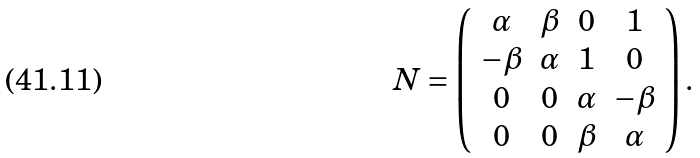Convert formula to latex. <formula><loc_0><loc_0><loc_500><loc_500>N = \left ( \begin{array} { c c c c } \alpha & \beta & 0 & 1 \\ - \beta & \alpha & 1 & 0 \\ 0 & 0 & \alpha & - \beta \\ 0 & 0 & \beta & \alpha \end{array} \right ) .</formula> 